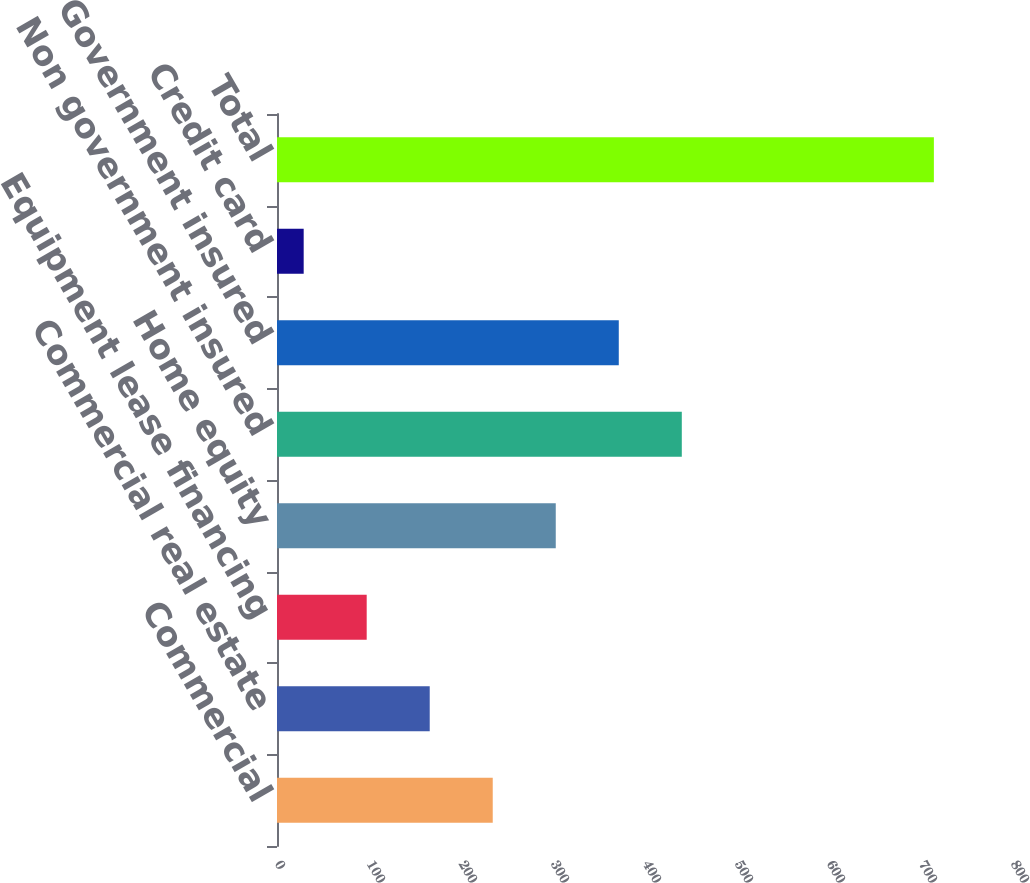<chart> <loc_0><loc_0><loc_500><loc_500><bar_chart><fcel>Commercial<fcel>Commercial real estate<fcel>Equipment lease financing<fcel>Home equity<fcel>Non government insured<fcel>Government insured<fcel>Credit card<fcel>Total<nl><fcel>234.5<fcel>166<fcel>97.5<fcel>303<fcel>440<fcel>371.5<fcel>29<fcel>714<nl></chart> 